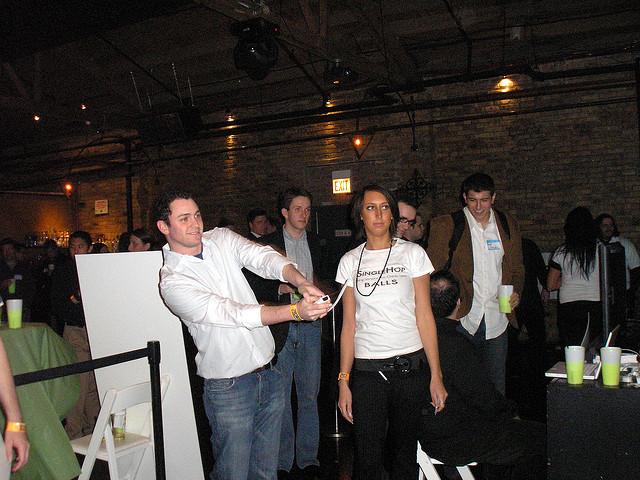What are the men wearing?
Write a very short answer. Shirt. What does the lady's shirt say?
Give a very brief answer. Balls. Why is the man leaning?
Write a very short answer. Playing wii. What is the woman staring at?
Short answer required. Tv. 